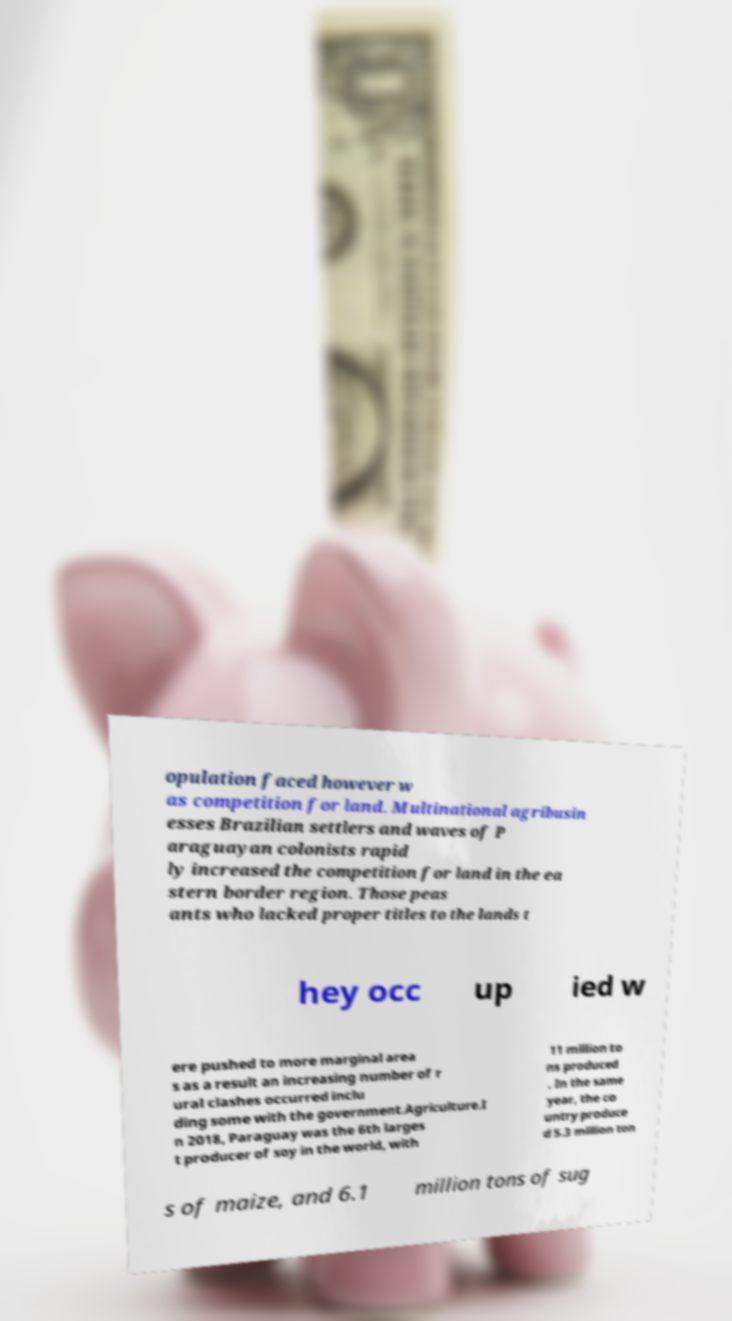Can you read and provide the text displayed in the image?This photo seems to have some interesting text. Can you extract and type it out for me? opulation faced however w as competition for land. Multinational agribusin esses Brazilian settlers and waves of P araguayan colonists rapid ly increased the competition for land in the ea stern border region. Those peas ants who lacked proper titles to the lands t hey occ up ied w ere pushed to more marginal area s as a result an increasing number of r ural clashes occurred inclu ding some with the government.Agriculture.I n 2018, Paraguay was the 6th larges t producer of soy in the world, with 11 million to ns produced . In the same year, the co untry produce d 5.3 million ton s of maize, and 6.1 million tons of sug 